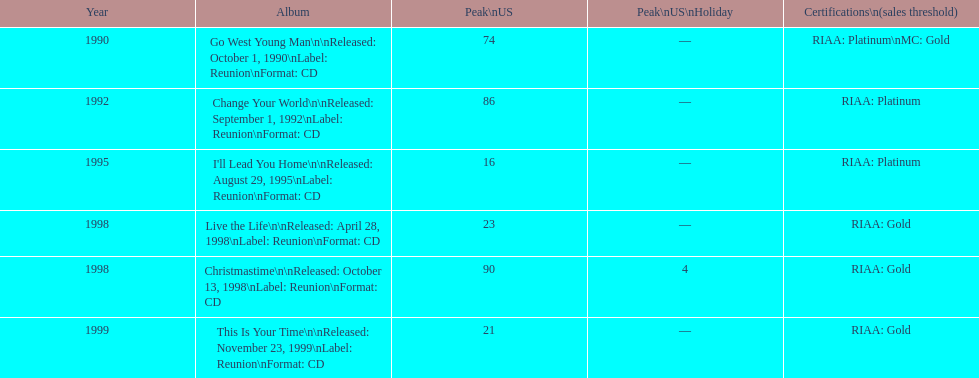What michael w smith album was released before his christmastime album? Live the Life. 